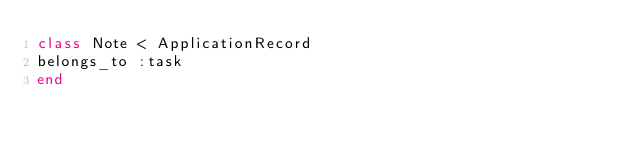Convert code to text. <code><loc_0><loc_0><loc_500><loc_500><_Ruby_>class Note < ApplicationRecord
belongs_to :task
end
</code> 